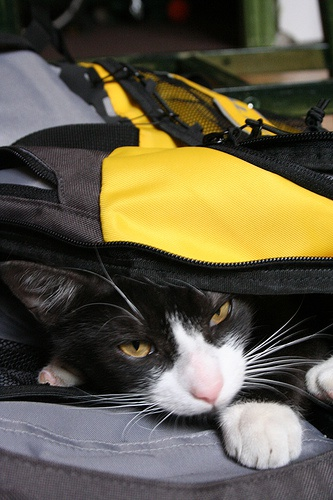Describe the objects in this image and their specific colors. I can see backpack in black, gold, and gray tones and cat in black, lightgray, gray, and darkgray tones in this image. 